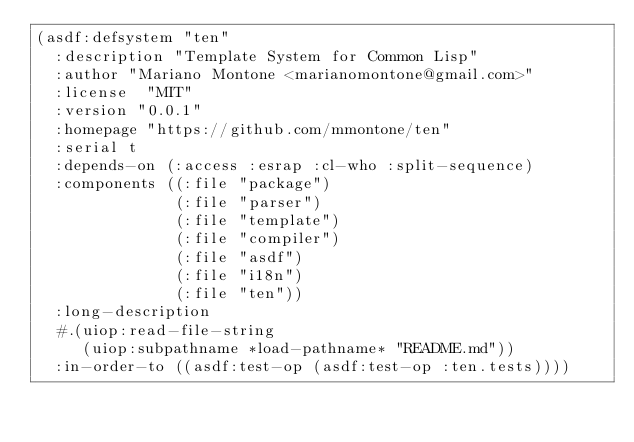Convert code to text. <code><loc_0><loc_0><loc_500><loc_500><_Lisp_>(asdf:defsystem "ten"
  :description "Template System for Common Lisp"
  :author "Mariano Montone <marianomontone@gmail.com>"
  :license  "MIT"
  :version "0.0.1"
  :homepage "https://github.com/mmontone/ten"
  :serial t
  :depends-on (:access :esrap :cl-who :split-sequence)
  :components ((:file "package")
               (:file "parser")
               (:file "template")
               (:file "compiler")
               (:file "asdf")
               (:file "i18n")
               (:file "ten"))
  :long-description
  #.(uiop:read-file-string
     (uiop:subpathname *load-pathname* "README.md"))
  :in-order-to ((asdf:test-op (asdf:test-op :ten.tests))))
</code> 